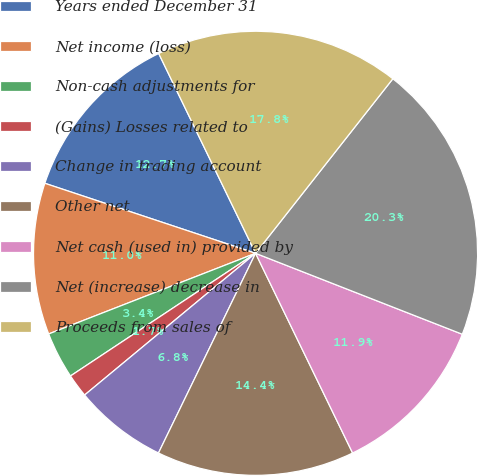Convert chart. <chart><loc_0><loc_0><loc_500><loc_500><pie_chart><fcel>Years ended December 31<fcel>Net income (loss)<fcel>Non-cash adjustments for<fcel>(Gains) Losses related to<fcel>Change in trading account<fcel>Other net<fcel>Net cash (used in) provided by<fcel>Net (increase) decrease in<fcel>Proceeds from sales of<nl><fcel>12.71%<fcel>11.02%<fcel>3.4%<fcel>1.7%<fcel>6.78%<fcel>14.4%<fcel>11.86%<fcel>20.33%<fcel>17.79%<nl></chart> 